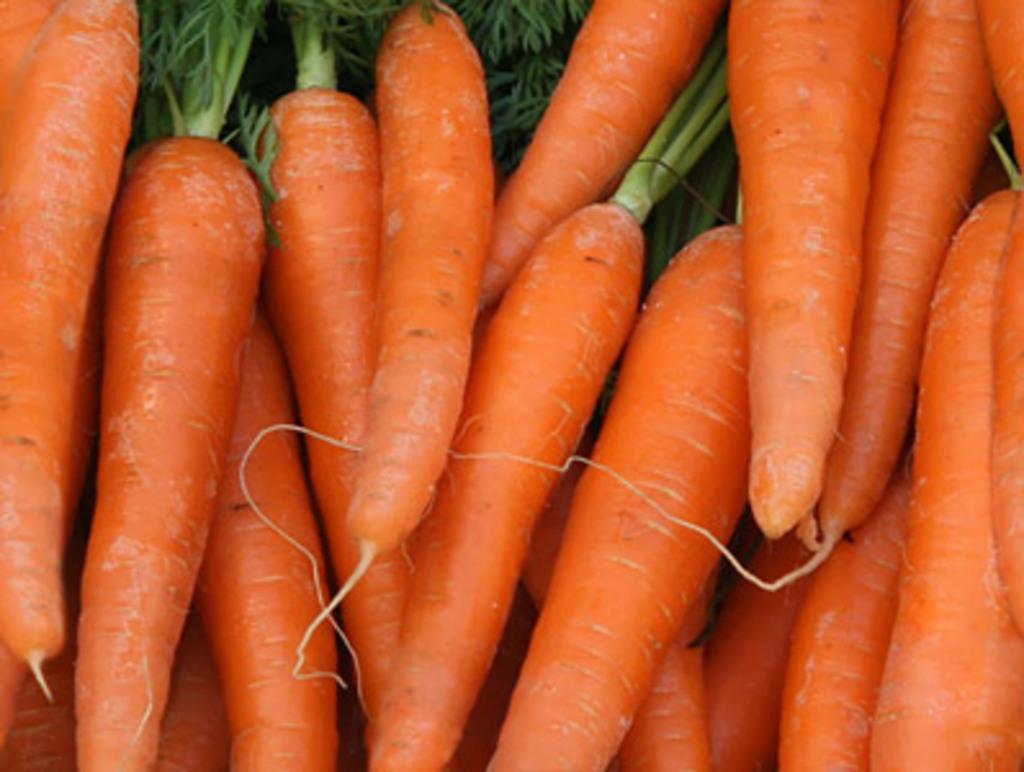Describe this image in one or two sentences. There are many orange carrots with leaves. 